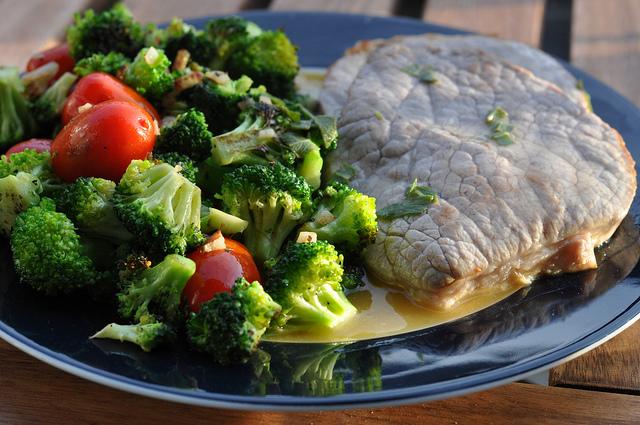What are the red thing on the plate?
Concise answer only. Tomatoes. Is there ice cream on this plate?
Be succinct. No. Is the meat cooke?
Quick response, please. Yes. 